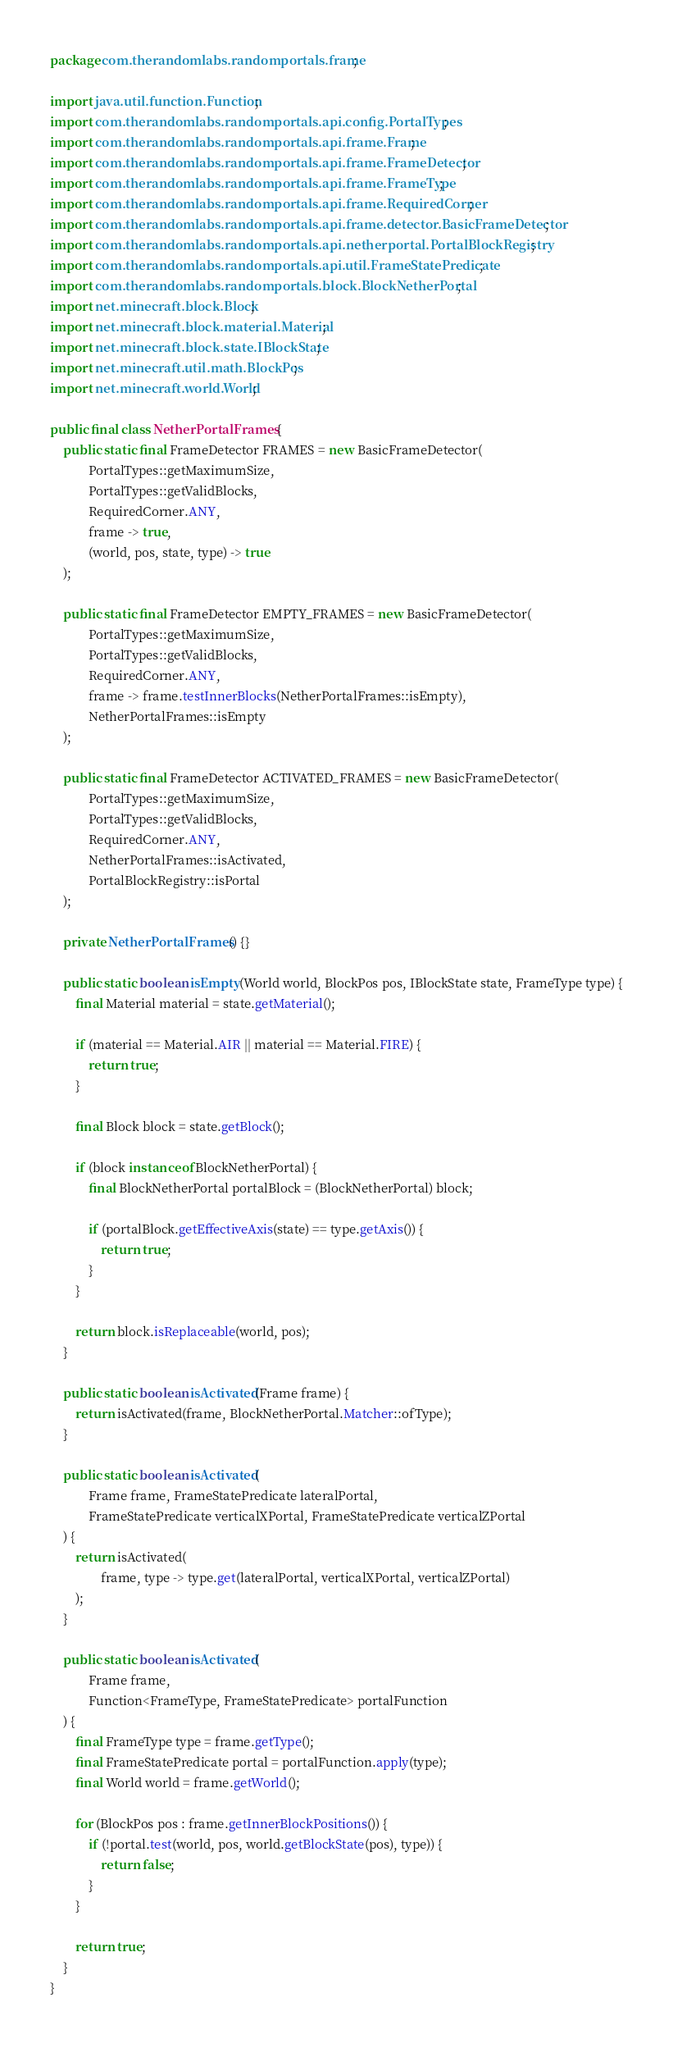<code> <loc_0><loc_0><loc_500><loc_500><_Java_>package com.therandomlabs.randomportals.frame;

import java.util.function.Function;
import com.therandomlabs.randomportals.api.config.PortalTypes;
import com.therandomlabs.randomportals.api.frame.Frame;
import com.therandomlabs.randomportals.api.frame.FrameDetector;
import com.therandomlabs.randomportals.api.frame.FrameType;
import com.therandomlabs.randomportals.api.frame.RequiredCorner;
import com.therandomlabs.randomportals.api.frame.detector.BasicFrameDetector;
import com.therandomlabs.randomportals.api.netherportal.PortalBlockRegistry;
import com.therandomlabs.randomportals.api.util.FrameStatePredicate;
import com.therandomlabs.randomportals.block.BlockNetherPortal;
import net.minecraft.block.Block;
import net.minecraft.block.material.Material;
import net.minecraft.block.state.IBlockState;
import net.minecraft.util.math.BlockPos;
import net.minecraft.world.World;

public final class NetherPortalFrames {
	public static final FrameDetector FRAMES = new BasicFrameDetector(
			PortalTypes::getMaximumSize,
			PortalTypes::getValidBlocks,
			RequiredCorner.ANY,
			frame -> true,
			(world, pos, state, type) -> true
	);

	public static final FrameDetector EMPTY_FRAMES = new BasicFrameDetector(
			PortalTypes::getMaximumSize,
			PortalTypes::getValidBlocks,
			RequiredCorner.ANY,
			frame -> frame.testInnerBlocks(NetherPortalFrames::isEmpty),
			NetherPortalFrames::isEmpty
	);

	public static final FrameDetector ACTIVATED_FRAMES = new BasicFrameDetector(
			PortalTypes::getMaximumSize,
			PortalTypes::getValidBlocks,
			RequiredCorner.ANY,
			NetherPortalFrames::isActivated,
			PortalBlockRegistry::isPortal
	);

	private NetherPortalFrames() {}

	public static boolean isEmpty(World world, BlockPos pos, IBlockState state, FrameType type) {
		final Material material = state.getMaterial();

		if (material == Material.AIR || material == Material.FIRE) {
			return true;
		}

		final Block block = state.getBlock();

		if (block instanceof BlockNetherPortal) {
			final BlockNetherPortal portalBlock = (BlockNetherPortal) block;

			if (portalBlock.getEffectiveAxis(state) == type.getAxis()) {
				return true;
			}
		}

		return block.isReplaceable(world, pos);
	}

	public static boolean isActivated(Frame frame) {
		return isActivated(frame, BlockNetherPortal.Matcher::ofType);
	}

	public static boolean isActivated(
			Frame frame, FrameStatePredicate lateralPortal,
			FrameStatePredicate verticalXPortal, FrameStatePredicate verticalZPortal
	) {
		return isActivated(
				frame, type -> type.get(lateralPortal, verticalXPortal, verticalZPortal)
		);
	}

	public static boolean isActivated(
			Frame frame,
			Function<FrameType, FrameStatePredicate> portalFunction
	) {
		final FrameType type = frame.getType();
		final FrameStatePredicate portal = portalFunction.apply(type);
		final World world = frame.getWorld();

		for (BlockPos pos : frame.getInnerBlockPositions()) {
			if (!portal.test(world, pos, world.getBlockState(pos), type)) {
				return false;
			}
		}

		return true;
	}
}
</code> 